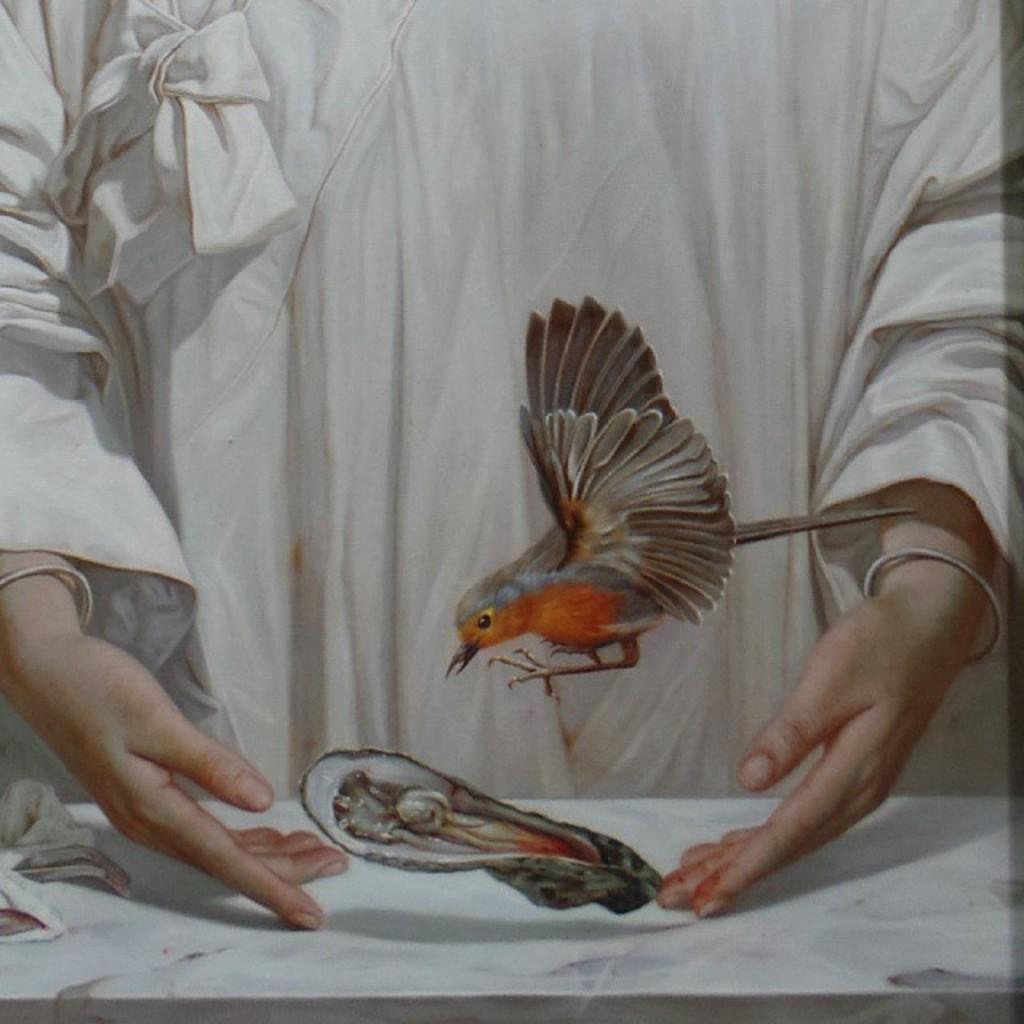How would you summarize this image in a sentence or two? In this image we can see a painting. In this image we can see a person, bird and other objects. 